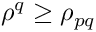<formula> <loc_0><loc_0><loc_500><loc_500>\rho ^ { q } \geq \rho _ { p q }</formula> 